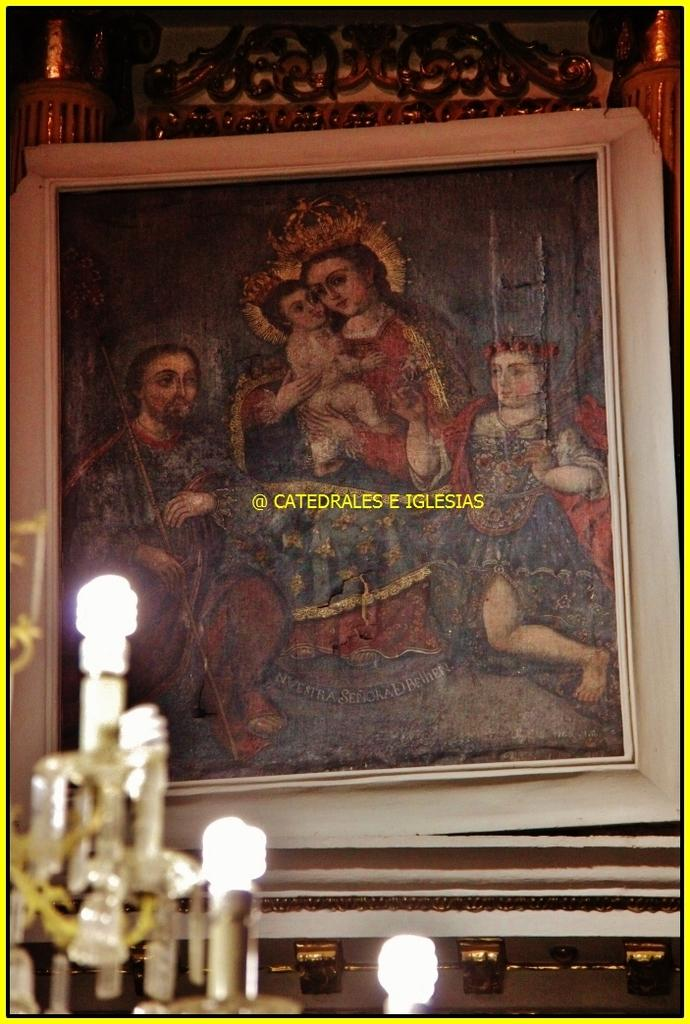What can be seen on the left side of the image? There are lights on the left side of the image. What is located on the wall in the background of the image? There is a frame on the wall in the background of the image. What is written or depicted on the frame? There is text on the frame. Can you describe the box that is placed near the seashore in the image? There is no box or seashore present in the image; it only features lights, a frame on the wall, and text on the frame. 